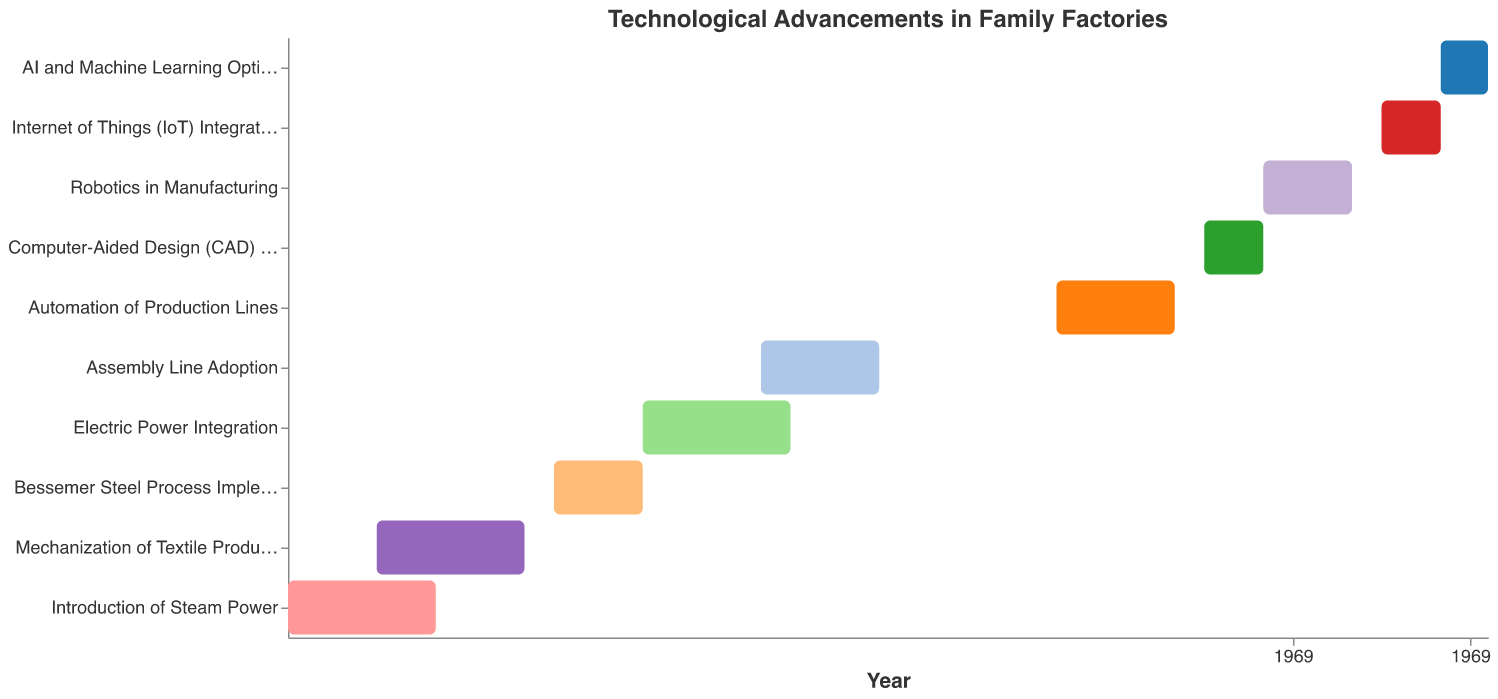What is the duration of the "Introduction of Steam Power" phase? The "Introduction of Steam Power" phase starts in 1820 and ends in 1845. The duration is calculated by subtracting the start year from the end year: 1845 - 1820 = 25 years.
Answer: 25 years Which phase started in 1950? According to the data provided, "Automation of Production Lines" started in 1950.
Answer: "Automation of Production Lines" What are the starting and ending years of the "Electric Power Integration" phase? The "Electric Power Integration" phase starts in 1880 and ends in 1905 as indicated in the data.
Answer: 1880 - 1905 Between which two phases was the "Bessemer Steel Process Implementation" implemented? The "Bessemer Steel Process Implementation" phase starts from 1865 to 1880. It was implemented between "Mechanization of Textile Production" (1835-1860) and "Electric Power Integration" (1880-1905).
Answer: "Mechanization of Textile Production" and "Electric Power Integration" Which phase has the longest duration? To find the longest duration, we calculate the number of years for each phase and compare. The "Robotics in Manufacturing" phase (1985-2000) lasted for 15 years, which is the longest duration among all phases.
Answer: "Robotics in Manufacturing" Which advancements overlap with the "Assembly Line Adoption" phase? To determine the overlap periods, we look at phases running between 1900 and 1920. The overlapping phases are: "Electric Power Integration" (1880-1905) and "Assembly Line Adoption" (1900-1920).
Answer: "Electric Power Integration" How many phases took place between the 19th century and the 20th century? The phases spanning between 1800 and 1900 are: "Introduction of Steam Power" (1820-1845), "Mechanization of Textile Production" (1835-1860), "Bessemer Steel Process Implementation" (1865-1880), and "Electric Power Integration" (1880-1905). There are four phases that were initiated or concluded in the 19th century.
Answer: Four phases Which phase immediately follows "Computer-Aided Design (CAD) Implementation"? The "Computer-Aided Design (CAD) Implementation" phase runs from 1975 to 1985. The next phase in the chronological order is "Robotics in Manufacturing," starting in 1985.
Answer: "Robotics in Manufacturing" 